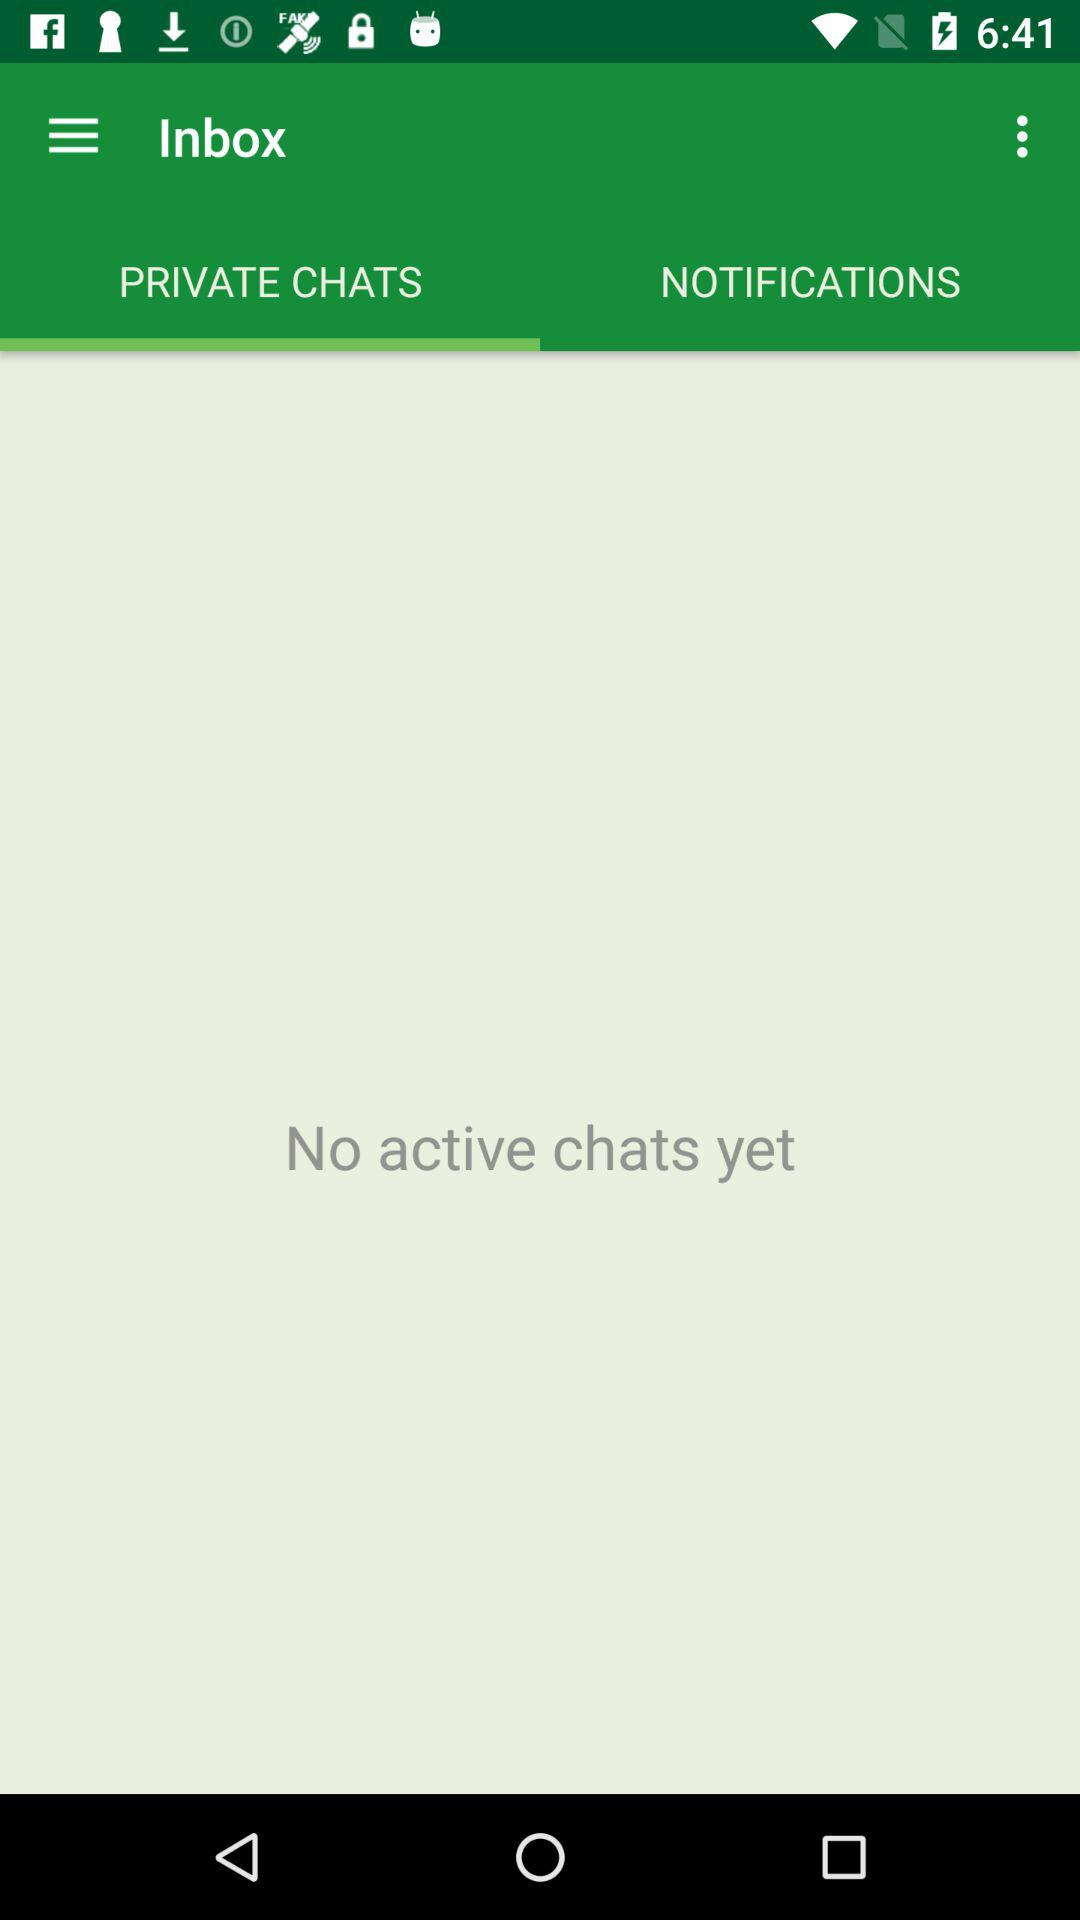Which tab has been selected? The tab that has been selected is "PRIVATE CHATS". 